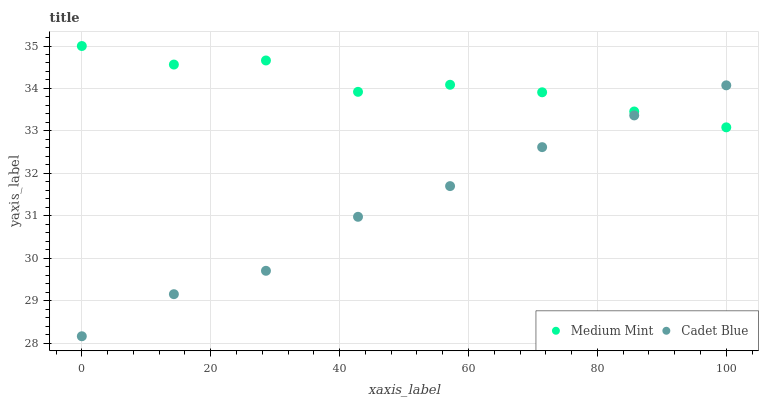Does Cadet Blue have the minimum area under the curve?
Answer yes or no. Yes. Does Medium Mint have the maximum area under the curve?
Answer yes or no. Yes. Does Cadet Blue have the maximum area under the curve?
Answer yes or no. No. Is Cadet Blue the smoothest?
Answer yes or no. Yes. Is Medium Mint the roughest?
Answer yes or no. Yes. Is Cadet Blue the roughest?
Answer yes or no. No. Does Cadet Blue have the lowest value?
Answer yes or no. Yes. Does Medium Mint have the highest value?
Answer yes or no. Yes. Does Cadet Blue have the highest value?
Answer yes or no. No. Does Cadet Blue intersect Medium Mint?
Answer yes or no. Yes. Is Cadet Blue less than Medium Mint?
Answer yes or no. No. Is Cadet Blue greater than Medium Mint?
Answer yes or no. No. 